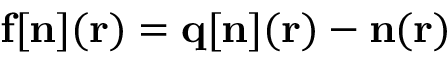Convert formula to latex. <formula><loc_0><loc_0><loc_500><loc_500>{ f } [ { n } ] ( { r } ) = { q [ n ] } ( { r } ) - { n } ( { r } )</formula> 